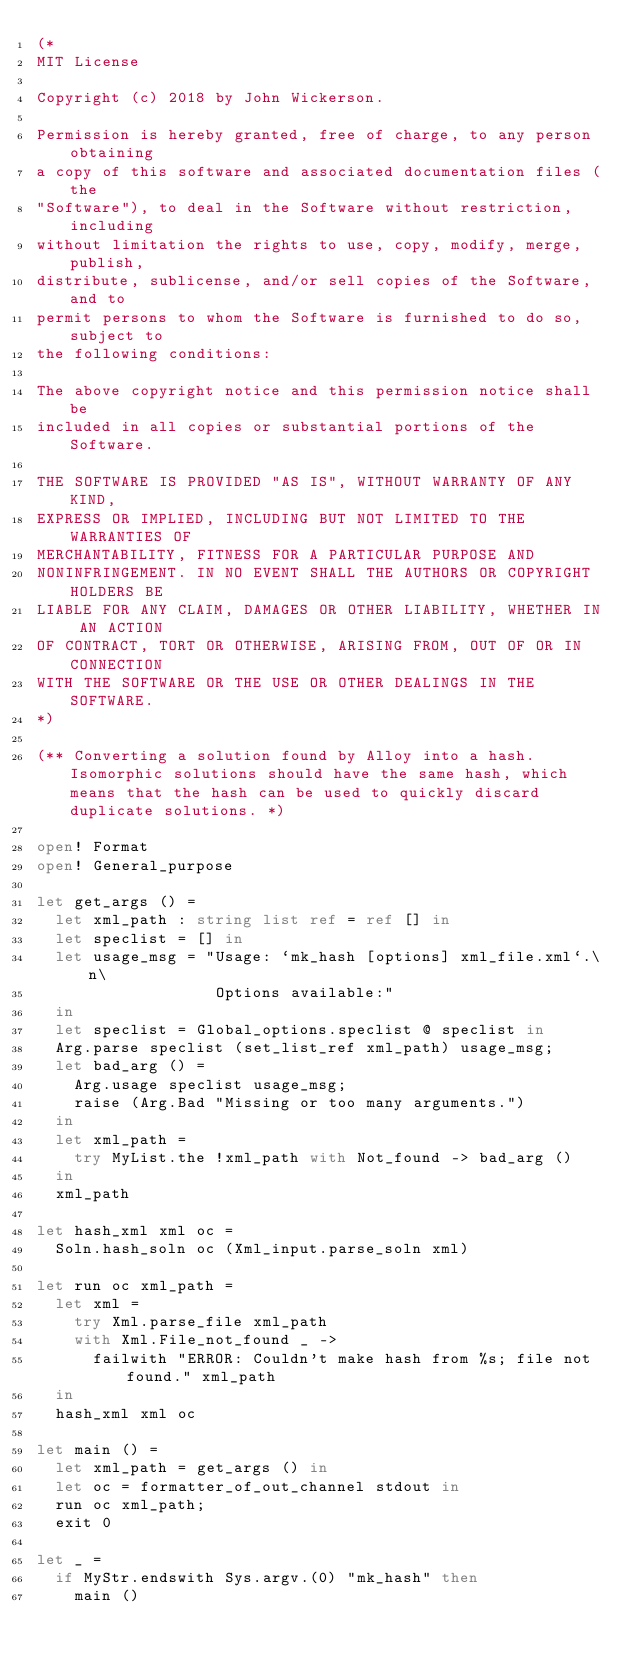Convert code to text. <code><loc_0><loc_0><loc_500><loc_500><_OCaml_>(*
MIT License

Copyright (c) 2018 by John Wickerson.

Permission is hereby granted, free of charge, to any person obtaining
a copy of this software and associated documentation files (the
"Software"), to deal in the Software without restriction, including
without limitation the rights to use, copy, modify, merge, publish,
distribute, sublicense, and/or sell copies of the Software, and to
permit persons to whom the Software is furnished to do so, subject to
the following conditions:

The above copyright notice and this permission notice shall be
included in all copies or substantial portions of the Software.

THE SOFTWARE IS PROVIDED "AS IS", WITHOUT WARRANTY OF ANY KIND,
EXPRESS OR IMPLIED, INCLUDING BUT NOT LIMITED TO THE WARRANTIES OF
MERCHANTABILITY, FITNESS FOR A PARTICULAR PURPOSE AND
NONINFRINGEMENT. IN NO EVENT SHALL THE AUTHORS OR COPYRIGHT HOLDERS BE
LIABLE FOR ANY CLAIM, DAMAGES OR OTHER LIABILITY, WHETHER IN AN ACTION
OF CONTRACT, TORT OR OTHERWISE, ARISING FROM, OUT OF OR IN CONNECTION
WITH THE SOFTWARE OR THE USE OR OTHER DEALINGS IN THE SOFTWARE.
*)

(** Converting a solution found by Alloy into a hash. Isomorphic solutions should have the same hash, which means that the hash can be used to quickly discard duplicate solutions. *)

open! Format
open! General_purpose

let get_args () =
  let xml_path : string list ref = ref [] in
  let speclist = [] in
  let usage_msg = "Usage: `mk_hash [options] xml_file.xml`.\n\
                   Options available:"
  in
  let speclist = Global_options.speclist @ speclist in
  Arg.parse speclist (set_list_ref xml_path) usage_msg;
  let bad_arg () =
    Arg.usage speclist usage_msg;
    raise (Arg.Bad "Missing or too many arguments.")
  in
  let xml_path =
    try MyList.the !xml_path with Not_found -> bad_arg ()
  in
  xml_path

let hash_xml xml oc =
  Soln.hash_soln oc (Xml_input.parse_soln xml)
  
let run oc xml_path =
  let xml =
    try Xml.parse_file xml_path
    with Xml.File_not_found _ ->
      failwith "ERROR: Couldn't make hash from %s; file not found." xml_path
  in
  hash_xml xml oc
  
let main () =
  let xml_path = get_args () in
  let oc = formatter_of_out_channel stdout in
  run oc xml_path;
  exit 0

let _ =
  if MyStr.endswith Sys.argv.(0) "mk_hash" then
    main ()
</code> 